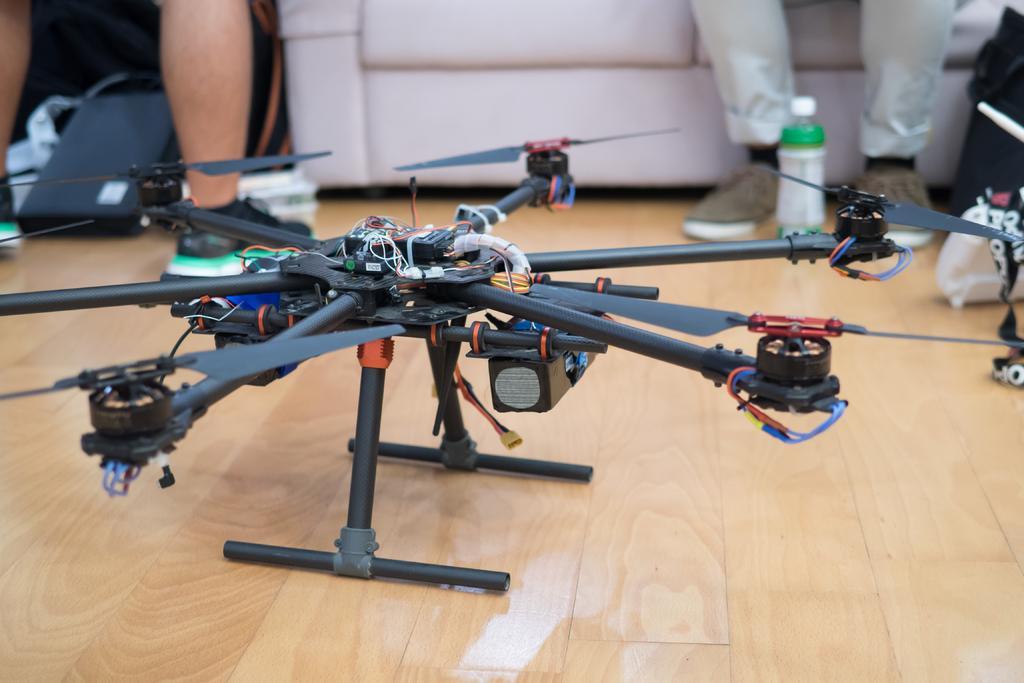Please provide a concise description of this image. In the image there is some gadget kept on the floor and around that gadget there are some other things and there are legs of two people visible in the image. 